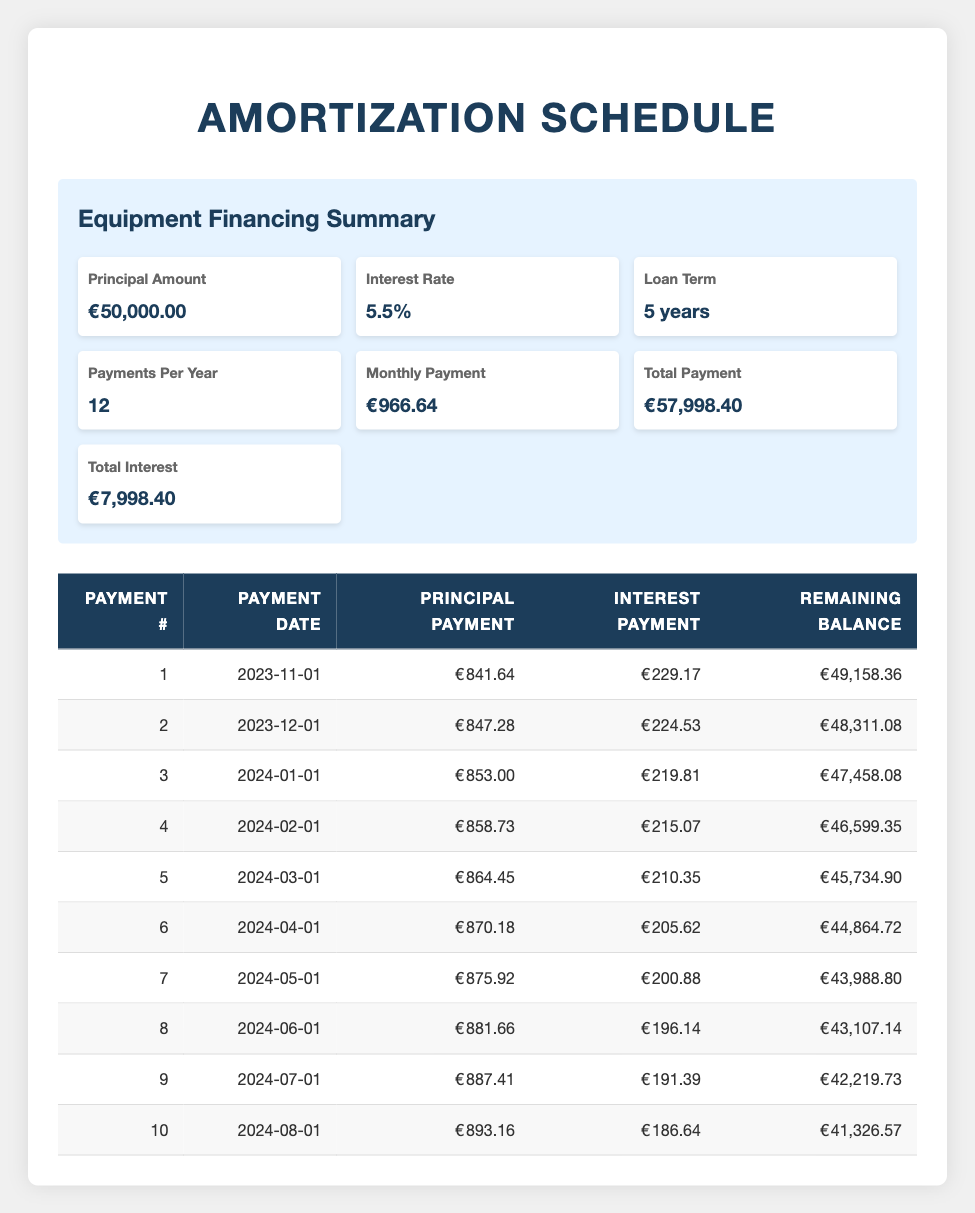What is the monthly payment for the equipment financing? The table shows a summary of equipment financing where the "Monthly Payment" value is listed. It states that the monthly payment is €966.64.
Answer: 966.64 What is the total interest paid over the loan term? The summary section of the table explicitly states the "Total Interest" amount, which is €7,998.40, indicating the entire interest to be paid over the 5-year term.
Answer: 7998.40 How much is the principal payment for the second month? The amortization schedule section lists payment details, and the principal payment for the second payment number (payment date 2023-12-01) is shown as €847.28.
Answer: 847.28 Is the interest payment for the first month greater than that of the second month? By comparing the "Interest Payment" values for the first and second payments, we have €229.17 for the first month and €224.53 for the second month. Since €229.17 > €224.53, the statement is true.
Answer: Yes What is the remaining balance after the third payment? The amortization schedule displays the "Remaining Balance" for the third payment number (payment date 2024-01-01) as €47,458.08. This is a direct retrieval from the table.
Answer: 47458.08 What is the average principal payment over the first five months? The principal payments for the first five months are €841.64, €847.28, €853.00, €858.73, and €864.45. The average is calculated as (841.64 + 847.28 + 853.00 + 858.73 + 864.45) / 5 = €853.42.
Answer: 853.42 How much did the remaining balance drop from the first month to the fifth month? The remaining balance after the first payment is €49,158.36 and after the fifth payment it is €45,734.90. To find the drop, subtract the fifth month's balance from the first month's balance: €49,158.36 - €45,734.90 = €3,423.46.
Answer: 3423.46 Is the monthly payment consistent across all payments? The table indicates a fixed "Monthly Payment" as €966.64, which implies consistency across all payments. This means that every month the amount remains the same.
Answer: Yes What is the total payment made after the first three months? The monthly payment is €966.64. Thus, after three months, the total payment would be 3 x €966.64 = €2,899.92. This calculation involves multiplying the monthly payment by the number of months.
Answer: 2899.92 